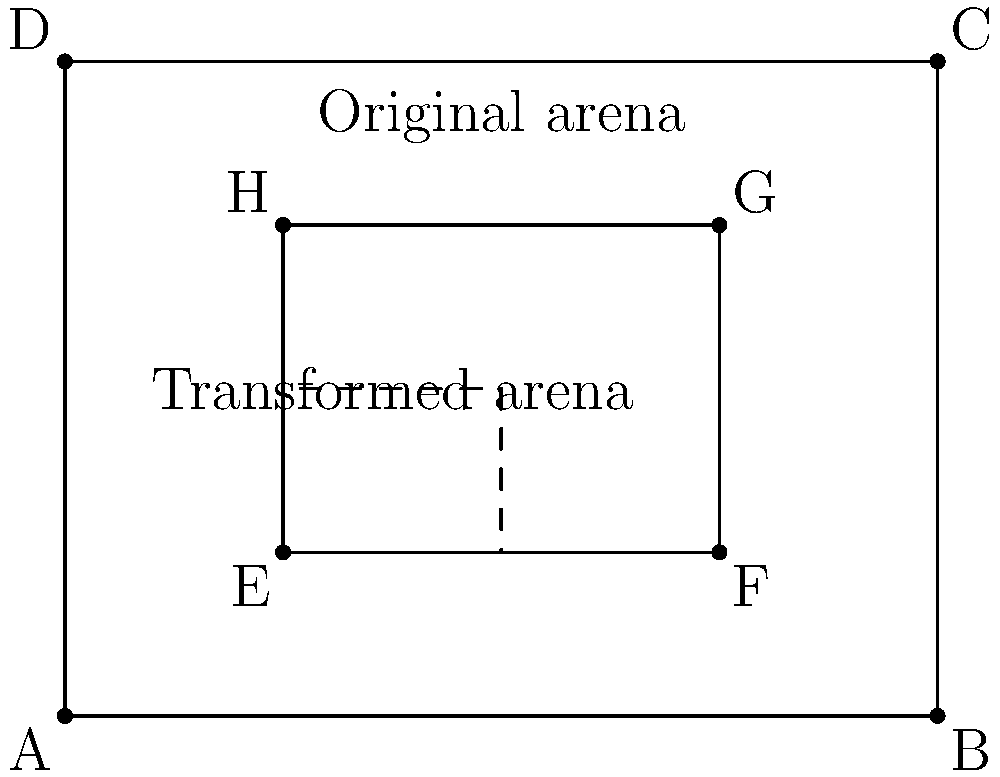As an experienced horseman designing an equestrian arena, you need to modify the existing layout. The current arena is represented by rectangle EFGH within the larger field ABCD. You want to create a smaller practice area by applying the following transformations to EFGH in order: a rotation of 90° clockwise around point E, followed by a dilation with a scale factor of 0.5 centered at E, and finally a translation of 2 units right and 1.5 units up. What is the area of the resulting transformed arena in square units? Let's approach this step-by-step:

1) The original arena EFGH:
   Width = 6 - 2 = 4 units
   Height = 4.5 - 1.5 = 3 units
   Area = 4 * 3 = 12 square units

2) Rotation of 90° clockwise around E:
   This changes the orientation but not the size, so the area remains 12 square units.

3) Dilation with scale factor 0.5 centered at E:
   New width = 4 * 0.5 = 2 units
   New height = 3 * 0.5 = 1.5 units
   New area = 2 * 1.5 = 3 square units

4) Translation:
   This moves the arena but doesn't change its size, so the area remains 3 square units.

Therefore, the area of the transformed arena is 3 square units.
Answer: 3 square units 